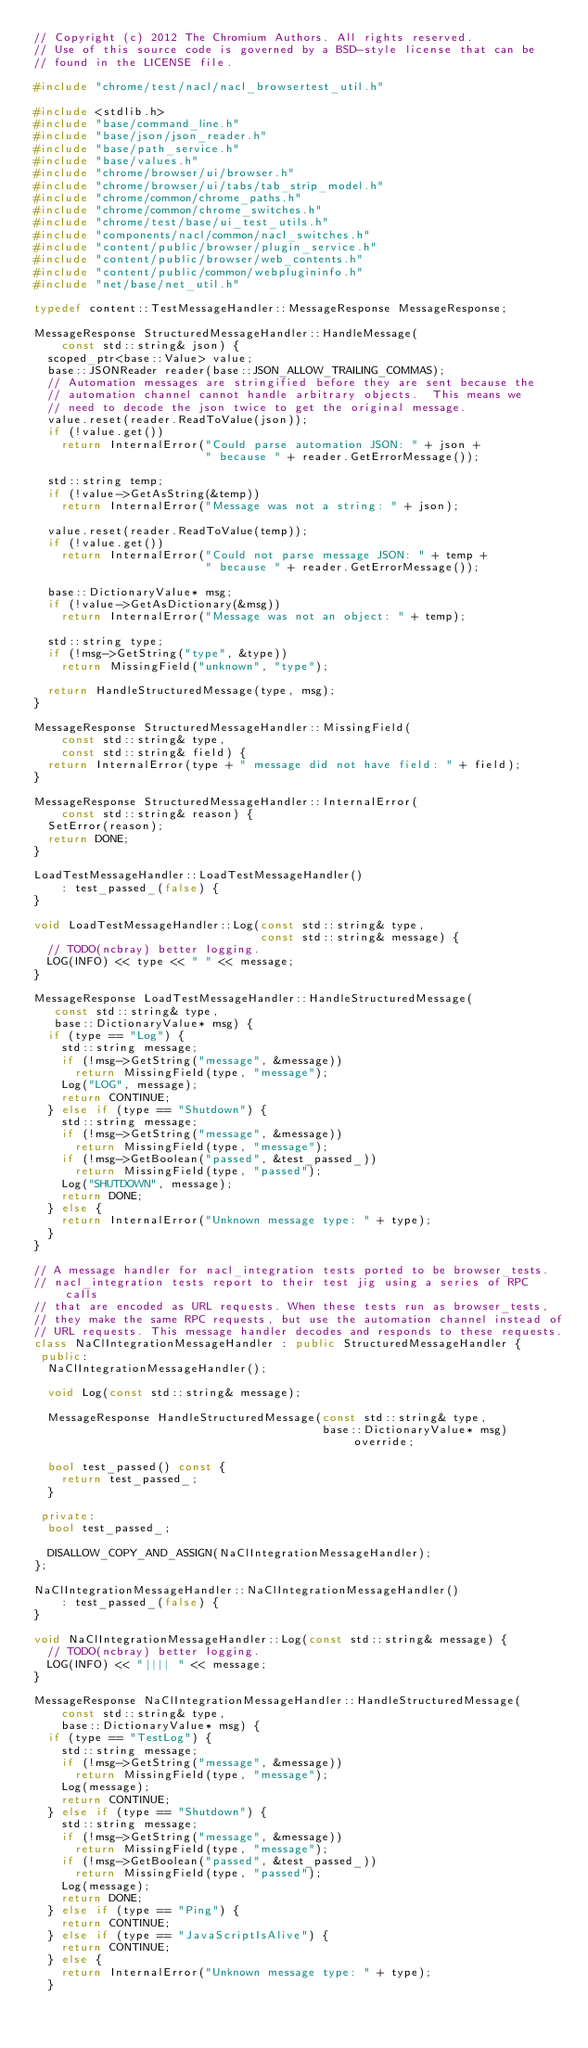Convert code to text. <code><loc_0><loc_0><loc_500><loc_500><_C++_>// Copyright (c) 2012 The Chromium Authors. All rights reserved.
// Use of this source code is governed by a BSD-style license that can be
// found in the LICENSE file.

#include "chrome/test/nacl/nacl_browsertest_util.h"

#include <stdlib.h>
#include "base/command_line.h"
#include "base/json/json_reader.h"
#include "base/path_service.h"
#include "base/values.h"
#include "chrome/browser/ui/browser.h"
#include "chrome/browser/ui/tabs/tab_strip_model.h"
#include "chrome/common/chrome_paths.h"
#include "chrome/common/chrome_switches.h"
#include "chrome/test/base/ui_test_utils.h"
#include "components/nacl/common/nacl_switches.h"
#include "content/public/browser/plugin_service.h"
#include "content/public/browser/web_contents.h"
#include "content/public/common/webplugininfo.h"
#include "net/base/net_util.h"

typedef content::TestMessageHandler::MessageResponse MessageResponse;

MessageResponse StructuredMessageHandler::HandleMessage(
    const std::string& json) {
  scoped_ptr<base::Value> value;
  base::JSONReader reader(base::JSON_ALLOW_TRAILING_COMMAS);
  // Automation messages are stringified before they are sent because the
  // automation channel cannot handle arbitrary objects.  This means we
  // need to decode the json twice to get the original message.
  value.reset(reader.ReadToValue(json));
  if (!value.get())
    return InternalError("Could parse automation JSON: " + json +
                         " because " + reader.GetErrorMessage());

  std::string temp;
  if (!value->GetAsString(&temp))
    return InternalError("Message was not a string: " + json);

  value.reset(reader.ReadToValue(temp));
  if (!value.get())
    return InternalError("Could not parse message JSON: " + temp +
                         " because " + reader.GetErrorMessage());

  base::DictionaryValue* msg;
  if (!value->GetAsDictionary(&msg))
    return InternalError("Message was not an object: " + temp);

  std::string type;
  if (!msg->GetString("type", &type))
    return MissingField("unknown", "type");

  return HandleStructuredMessage(type, msg);
}

MessageResponse StructuredMessageHandler::MissingField(
    const std::string& type,
    const std::string& field) {
  return InternalError(type + " message did not have field: " + field);
}

MessageResponse StructuredMessageHandler::InternalError(
    const std::string& reason) {
  SetError(reason);
  return DONE;
}

LoadTestMessageHandler::LoadTestMessageHandler()
    : test_passed_(false) {
}

void LoadTestMessageHandler::Log(const std::string& type,
                                 const std::string& message) {
  // TODO(ncbray) better logging.
  LOG(INFO) << type << " " << message;
}

MessageResponse LoadTestMessageHandler::HandleStructuredMessage(
   const std::string& type,
   base::DictionaryValue* msg) {
  if (type == "Log") {
    std::string message;
    if (!msg->GetString("message", &message))
      return MissingField(type, "message");
    Log("LOG", message);
    return CONTINUE;
  } else if (type == "Shutdown") {
    std::string message;
    if (!msg->GetString("message", &message))
      return MissingField(type, "message");
    if (!msg->GetBoolean("passed", &test_passed_))
      return MissingField(type, "passed");
    Log("SHUTDOWN", message);
    return DONE;
  } else {
    return InternalError("Unknown message type: " + type);
  }
}

// A message handler for nacl_integration tests ported to be browser_tests.
// nacl_integration tests report to their test jig using a series of RPC calls
// that are encoded as URL requests. When these tests run as browser_tests,
// they make the same RPC requests, but use the automation channel instead of
// URL requests. This message handler decodes and responds to these requests.
class NaClIntegrationMessageHandler : public StructuredMessageHandler {
 public:
  NaClIntegrationMessageHandler();

  void Log(const std::string& message);

  MessageResponse HandleStructuredMessage(const std::string& type,
                                          base::DictionaryValue* msg) override;

  bool test_passed() const {
    return test_passed_;
  }

 private:
  bool test_passed_;

  DISALLOW_COPY_AND_ASSIGN(NaClIntegrationMessageHandler);
};

NaClIntegrationMessageHandler::NaClIntegrationMessageHandler()
    : test_passed_(false) {
}

void NaClIntegrationMessageHandler::Log(const std::string& message) {
  // TODO(ncbray) better logging.
  LOG(INFO) << "|||| " << message;
}

MessageResponse NaClIntegrationMessageHandler::HandleStructuredMessage(
    const std::string& type,
    base::DictionaryValue* msg) {
  if (type == "TestLog") {
    std::string message;
    if (!msg->GetString("message", &message))
      return MissingField(type, "message");
    Log(message);
    return CONTINUE;
  } else if (type == "Shutdown") {
    std::string message;
    if (!msg->GetString("message", &message))
      return MissingField(type, "message");
    if (!msg->GetBoolean("passed", &test_passed_))
      return MissingField(type, "passed");
    Log(message);
    return DONE;
  } else if (type == "Ping") {
    return CONTINUE;
  } else if (type == "JavaScriptIsAlive") {
    return CONTINUE;
  } else {
    return InternalError("Unknown message type: " + type);
  }</code> 